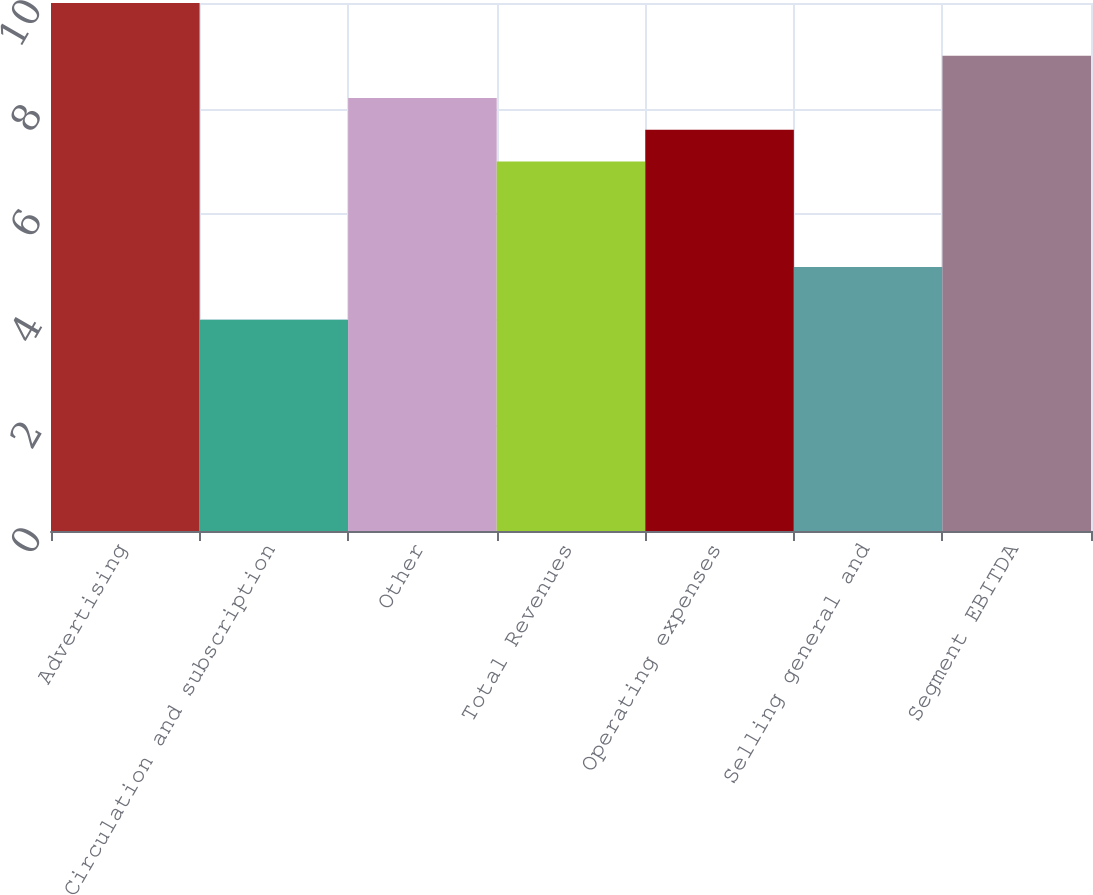Convert chart. <chart><loc_0><loc_0><loc_500><loc_500><bar_chart><fcel>Advertising<fcel>Circulation and subscription<fcel>Other<fcel>Total Revenues<fcel>Operating expenses<fcel>Selling general and<fcel>Segment EBITDA<nl><fcel>10<fcel>4<fcel>8.2<fcel>7<fcel>7.6<fcel>5<fcel>9<nl></chart> 